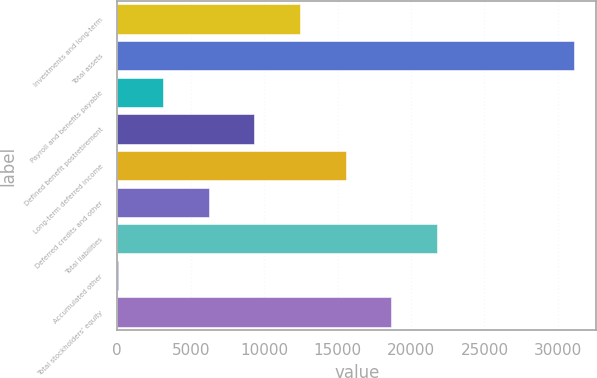Convert chart to OTSL. <chart><loc_0><loc_0><loc_500><loc_500><bar_chart><fcel>Investments and long-term<fcel>Total assets<fcel>Payroll and benefits payable<fcel>Defined benefit postretirement<fcel>Long-term deferred income<fcel>Deferred credits and other<fcel>Total liabilities<fcel>Accumulated other<fcel>Total stockholders' equity<nl><fcel>12441.4<fcel>31066<fcel>3129.1<fcel>9337.3<fcel>15545.5<fcel>6233.2<fcel>21753.7<fcel>25<fcel>18649.6<nl></chart> 